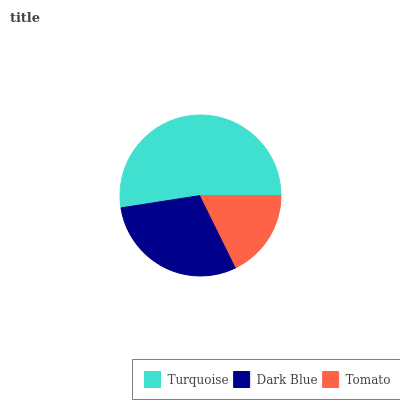Is Tomato the minimum?
Answer yes or no. Yes. Is Turquoise the maximum?
Answer yes or no. Yes. Is Dark Blue the minimum?
Answer yes or no. No. Is Dark Blue the maximum?
Answer yes or no. No. Is Turquoise greater than Dark Blue?
Answer yes or no. Yes. Is Dark Blue less than Turquoise?
Answer yes or no. Yes. Is Dark Blue greater than Turquoise?
Answer yes or no. No. Is Turquoise less than Dark Blue?
Answer yes or no. No. Is Dark Blue the high median?
Answer yes or no. Yes. Is Dark Blue the low median?
Answer yes or no. Yes. Is Turquoise the high median?
Answer yes or no. No. Is Turquoise the low median?
Answer yes or no. No. 